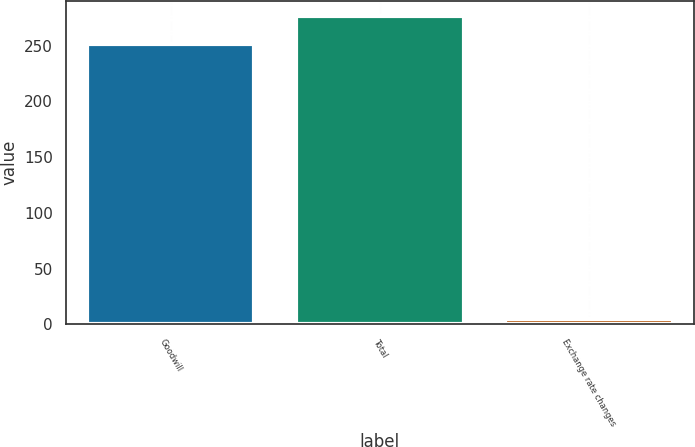<chart> <loc_0><loc_0><loc_500><loc_500><bar_chart><fcel>Goodwill<fcel>Total<fcel>Exchange rate changes<nl><fcel>252<fcel>276.7<fcel>5<nl></chart> 